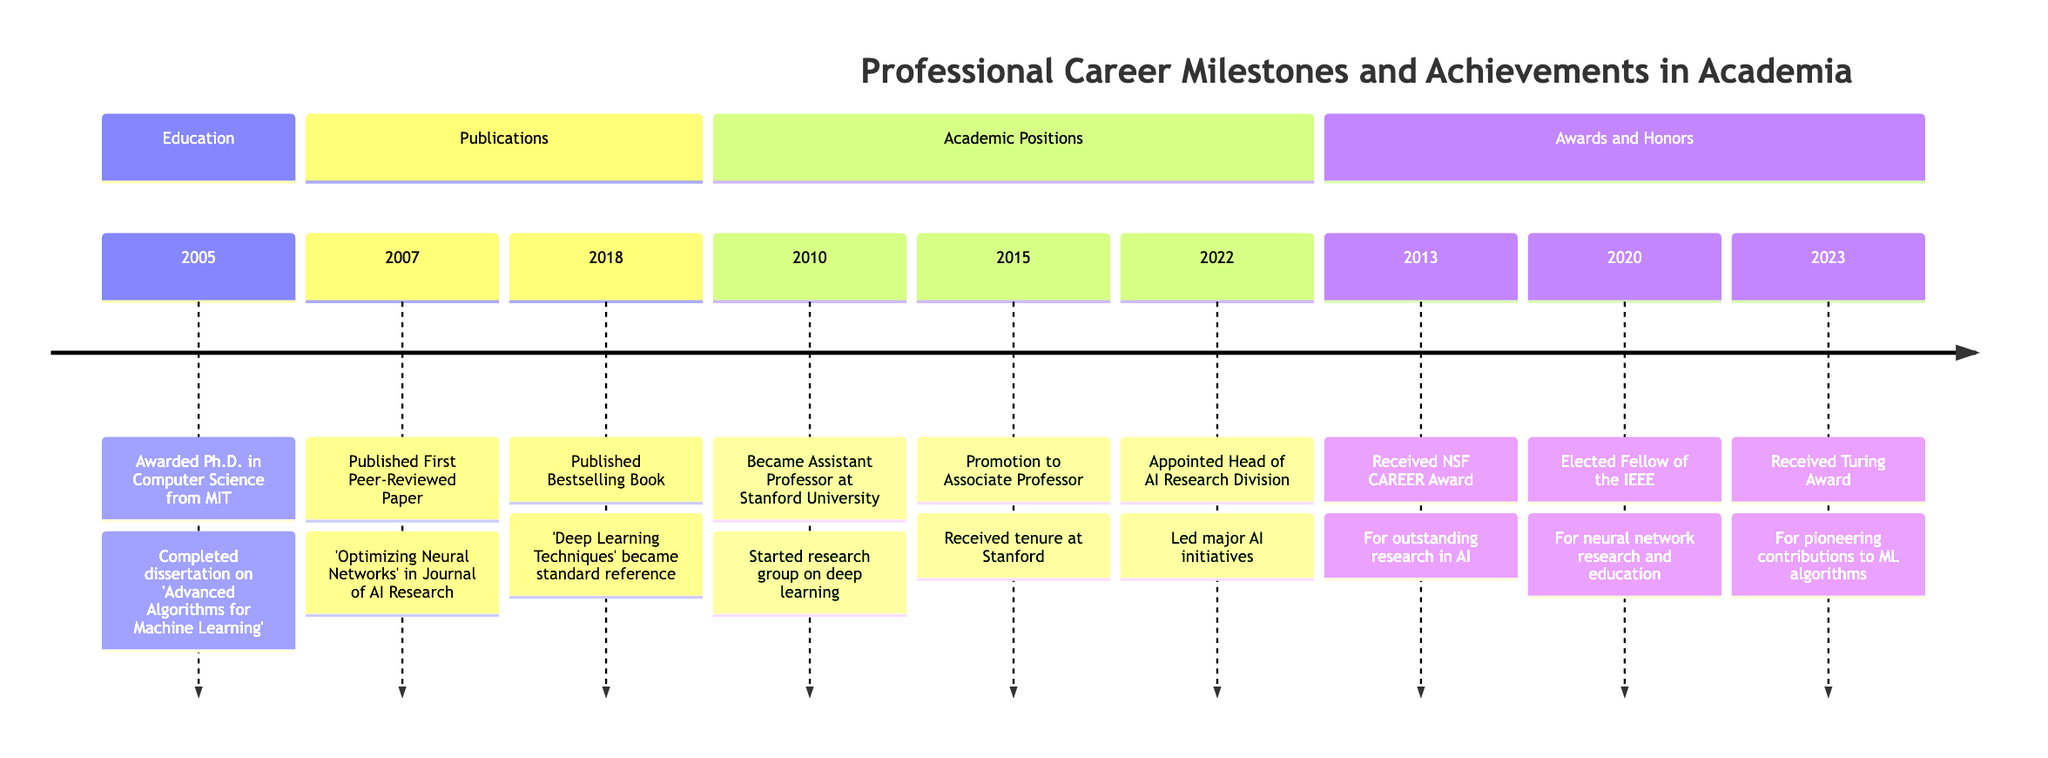What year was the Ph.D. awarded? The timeline states that the Ph.D. in Computer Science was awarded in 2005.
Answer: 2005 Who published the first peer-reviewed paper? The timeline indicates that the first peer-reviewed paper was authored by the individual whose career milestones are depicted, specifically titled 'Optimizing Neural Networks.'
Answer: Authored What significant award was received in 2013? According to the timeline, the award received in 2013 was the NSF CAREER Award.
Answer: NSF CAREER Award In which year did the individual become an Associate Professor? The timeline specifies that the promotion to Associate Professor occurred in 2015.
Answer: 2015 How many major academic positions are listed in the timeline? By counting the academic positions, there are three mentioned: Assistant Professor in 2010, promotion to Associate Professor in 2015, and Head of AI Research Division in 2022.
Answer: 3 What is the title of the bestselling book published? The timeline mentions the bestselling book published in 2018 is titled 'Deep Learning Techniques'.
Answer: Deep Learning Techniques What honor was received in 2020? The timeline notes that the individual was elected Fellow of the IEEE in 2020.
Answer: Fellow of the IEEE In what area did the individual focus their research group as an Assistant Professor? Upon becoming an Assistant Professor in 2010, the research group focused on deep learning, as stated in the timeline.
Answer: Deep learning Identify the last achievement listed in the timeline. The timeline concludes with the receipt of the Turing Award in 2023 for pioneering contributions to machine learning algorithms.
Answer: Turing Award 